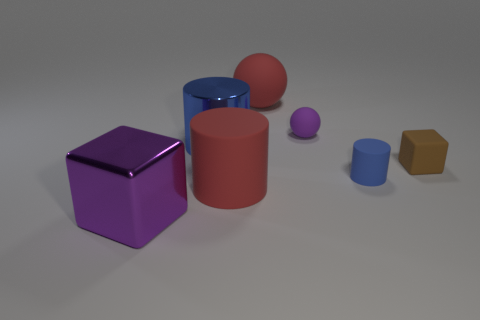Imagine these shapes are part of a children's toy set. Which educational concepts could a child learn from them? These shapes could offer a range of educational benefits for a child. They could learn about basic geometry by identifying the shapes such as spheres, cylinders, and a hexagonal prism. They might explore the concept of sizes by comparing the smaller and larger shapes. Recognizing and naming colors, understanding spatial relations like 'in front of' or 'to the right of,' and even beginning to grasp the principles of volume and surface area are other valuable educational concepts that could be derived from playing with these toy shapes. 